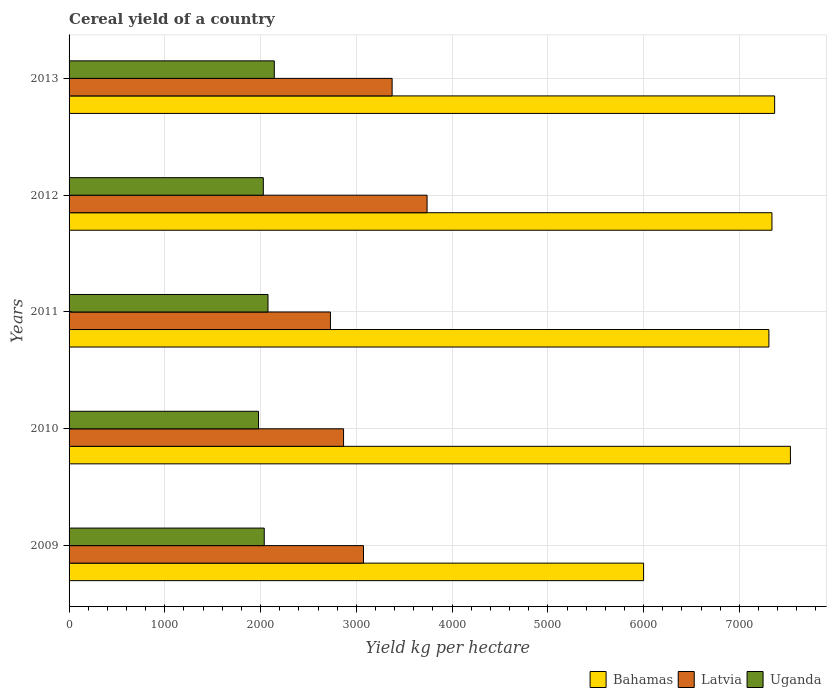How many different coloured bars are there?
Ensure brevity in your answer.  3. How many groups of bars are there?
Offer a very short reply. 5. How many bars are there on the 3rd tick from the bottom?
Provide a short and direct response. 3. In how many cases, is the number of bars for a given year not equal to the number of legend labels?
Offer a very short reply. 0. What is the total cereal yield in Uganda in 2010?
Provide a succinct answer. 1978.44. Across all years, what is the maximum total cereal yield in Uganda?
Offer a very short reply. 2143.29. Across all years, what is the minimum total cereal yield in Latvia?
Provide a short and direct response. 2729.47. In which year was the total cereal yield in Bahamas maximum?
Make the answer very short. 2010. What is the total total cereal yield in Latvia in the graph?
Provide a succinct answer. 1.58e+04. What is the difference between the total cereal yield in Bahamas in 2011 and that in 2012?
Keep it short and to the point. -31.91. What is the difference between the total cereal yield in Bahamas in 2009 and the total cereal yield in Latvia in 2011?
Provide a succinct answer. 3270.53. What is the average total cereal yield in Latvia per year?
Give a very brief answer. 3156.72. In the year 2013, what is the difference between the total cereal yield in Latvia and total cereal yield in Bahamas?
Your answer should be very brief. -3994.63. What is the ratio of the total cereal yield in Uganda in 2009 to that in 2011?
Provide a succinct answer. 0.98. Is the difference between the total cereal yield in Latvia in 2011 and 2012 greater than the difference between the total cereal yield in Bahamas in 2011 and 2012?
Your response must be concise. No. What is the difference between the highest and the second highest total cereal yield in Latvia?
Provide a succinct answer. 365.02. What is the difference between the highest and the lowest total cereal yield in Uganda?
Your response must be concise. 164.85. What does the 2nd bar from the top in 2012 represents?
Make the answer very short. Latvia. What does the 2nd bar from the bottom in 2011 represents?
Provide a short and direct response. Latvia. Is it the case that in every year, the sum of the total cereal yield in Uganda and total cereal yield in Bahamas is greater than the total cereal yield in Latvia?
Keep it short and to the point. Yes. How many bars are there?
Offer a very short reply. 15. Are all the bars in the graph horizontal?
Provide a succinct answer. Yes. Where does the legend appear in the graph?
Your answer should be compact. Bottom right. How many legend labels are there?
Give a very brief answer. 3. What is the title of the graph?
Make the answer very short. Cereal yield of a country. What is the label or title of the X-axis?
Provide a succinct answer. Yield kg per hectare. What is the label or title of the Y-axis?
Provide a succinct answer. Years. What is the Yield kg per hectare of Bahamas in 2009?
Ensure brevity in your answer.  6000. What is the Yield kg per hectare of Latvia in 2009?
Provide a short and direct response. 3074.88. What is the Yield kg per hectare of Uganda in 2009?
Your answer should be compact. 2038.33. What is the Yield kg per hectare of Bahamas in 2010?
Ensure brevity in your answer.  7533.33. What is the Yield kg per hectare in Latvia in 2010?
Your response must be concise. 2866.68. What is the Yield kg per hectare of Uganda in 2010?
Provide a succinct answer. 1978.44. What is the Yield kg per hectare of Bahamas in 2011?
Your answer should be compact. 7308.51. What is the Yield kg per hectare of Latvia in 2011?
Offer a terse response. 2729.47. What is the Yield kg per hectare in Uganda in 2011?
Your answer should be compact. 2077.56. What is the Yield kg per hectare of Bahamas in 2012?
Give a very brief answer. 7340.43. What is the Yield kg per hectare in Latvia in 2012?
Give a very brief answer. 3738.81. What is the Yield kg per hectare of Uganda in 2012?
Your response must be concise. 2028.6. What is the Yield kg per hectare of Bahamas in 2013?
Provide a short and direct response. 7368.42. What is the Yield kg per hectare of Latvia in 2013?
Offer a very short reply. 3373.79. What is the Yield kg per hectare of Uganda in 2013?
Your response must be concise. 2143.29. Across all years, what is the maximum Yield kg per hectare in Bahamas?
Your answer should be compact. 7533.33. Across all years, what is the maximum Yield kg per hectare of Latvia?
Provide a short and direct response. 3738.81. Across all years, what is the maximum Yield kg per hectare of Uganda?
Offer a terse response. 2143.29. Across all years, what is the minimum Yield kg per hectare of Bahamas?
Offer a terse response. 6000. Across all years, what is the minimum Yield kg per hectare in Latvia?
Make the answer very short. 2729.47. Across all years, what is the minimum Yield kg per hectare in Uganda?
Your response must be concise. 1978.44. What is the total Yield kg per hectare of Bahamas in the graph?
Offer a terse response. 3.56e+04. What is the total Yield kg per hectare in Latvia in the graph?
Make the answer very short. 1.58e+04. What is the total Yield kg per hectare in Uganda in the graph?
Provide a short and direct response. 1.03e+04. What is the difference between the Yield kg per hectare in Bahamas in 2009 and that in 2010?
Make the answer very short. -1533.33. What is the difference between the Yield kg per hectare of Latvia in 2009 and that in 2010?
Offer a very short reply. 208.19. What is the difference between the Yield kg per hectare of Uganda in 2009 and that in 2010?
Give a very brief answer. 59.88. What is the difference between the Yield kg per hectare of Bahamas in 2009 and that in 2011?
Your response must be concise. -1308.51. What is the difference between the Yield kg per hectare in Latvia in 2009 and that in 2011?
Your answer should be compact. 345.4. What is the difference between the Yield kg per hectare of Uganda in 2009 and that in 2011?
Give a very brief answer. -39.23. What is the difference between the Yield kg per hectare in Bahamas in 2009 and that in 2012?
Your answer should be very brief. -1340.43. What is the difference between the Yield kg per hectare in Latvia in 2009 and that in 2012?
Your response must be concise. -663.93. What is the difference between the Yield kg per hectare in Uganda in 2009 and that in 2012?
Give a very brief answer. 9.72. What is the difference between the Yield kg per hectare in Bahamas in 2009 and that in 2013?
Ensure brevity in your answer.  -1368.42. What is the difference between the Yield kg per hectare in Latvia in 2009 and that in 2013?
Offer a terse response. -298.91. What is the difference between the Yield kg per hectare in Uganda in 2009 and that in 2013?
Give a very brief answer. -104.97. What is the difference between the Yield kg per hectare in Bahamas in 2010 and that in 2011?
Keep it short and to the point. 224.82. What is the difference between the Yield kg per hectare in Latvia in 2010 and that in 2011?
Provide a short and direct response. 137.21. What is the difference between the Yield kg per hectare in Uganda in 2010 and that in 2011?
Provide a succinct answer. -99.11. What is the difference between the Yield kg per hectare of Bahamas in 2010 and that in 2012?
Provide a short and direct response. 192.91. What is the difference between the Yield kg per hectare of Latvia in 2010 and that in 2012?
Provide a short and direct response. -872.13. What is the difference between the Yield kg per hectare of Uganda in 2010 and that in 2012?
Give a very brief answer. -50.16. What is the difference between the Yield kg per hectare of Bahamas in 2010 and that in 2013?
Give a very brief answer. 164.91. What is the difference between the Yield kg per hectare in Latvia in 2010 and that in 2013?
Make the answer very short. -507.11. What is the difference between the Yield kg per hectare in Uganda in 2010 and that in 2013?
Keep it short and to the point. -164.85. What is the difference between the Yield kg per hectare in Bahamas in 2011 and that in 2012?
Your answer should be compact. -31.91. What is the difference between the Yield kg per hectare in Latvia in 2011 and that in 2012?
Your response must be concise. -1009.33. What is the difference between the Yield kg per hectare in Uganda in 2011 and that in 2012?
Give a very brief answer. 48.95. What is the difference between the Yield kg per hectare in Bahamas in 2011 and that in 2013?
Offer a terse response. -59.91. What is the difference between the Yield kg per hectare in Latvia in 2011 and that in 2013?
Give a very brief answer. -644.32. What is the difference between the Yield kg per hectare of Uganda in 2011 and that in 2013?
Make the answer very short. -65.74. What is the difference between the Yield kg per hectare of Bahamas in 2012 and that in 2013?
Your answer should be very brief. -28. What is the difference between the Yield kg per hectare of Latvia in 2012 and that in 2013?
Your answer should be compact. 365.02. What is the difference between the Yield kg per hectare in Uganda in 2012 and that in 2013?
Your answer should be compact. -114.69. What is the difference between the Yield kg per hectare in Bahamas in 2009 and the Yield kg per hectare in Latvia in 2010?
Give a very brief answer. 3133.32. What is the difference between the Yield kg per hectare in Bahamas in 2009 and the Yield kg per hectare in Uganda in 2010?
Offer a very short reply. 4021.56. What is the difference between the Yield kg per hectare of Latvia in 2009 and the Yield kg per hectare of Uganda in 2010?
Your response must be concise. 1096.43. What is the difference between the Yield kg per hectare in Bahamas in 2009 and the Yield kg per hectare in Latvia in 2011?
Your answer should be very brief. 3270.53. What is the difference between the Yield kg per hectare in Bahamas in 2009 and the Yield kg per hectare in Uganda in 2011?
Keep it short and to the point. 3922.44. What is the difference between the Yield kg per hectare in Latvia in 2009 and the Yield kg per hectare in Uganda in 2011?
Provide a succinct answer. 997.32. What is the difference between the Yield kg per hectare in Bahamas in 2009 and the Yield kg per hectare in Latvia in 2012?
Make the answer very short. 2261.19. What is the difference between the Yield kg per hectare of Bahamas in 2009 and the Yield kg per hectare of Uganda in 2012?
Your response must be concise. 3971.4. What is the difference between the Yield kg per hectare in Latvia in 2009 and the Yield kg per hectare in Uganda in 2012?
Your response must be concise. 1046.27. What is the difference between the Yield kg per hectare in Bahamas in 2009 and the Yield kg per hectare in Latvia in 2013?
Make the answer very short. 2626.21. What is the difference between the Yield kg per hectare in Bahamas in 2009 and the Yield kg per hectare in Uganda in 2013?
Provide a short and direct response. 3856.71. What is the difference between the Yield kg per hectare in Latvia in 2009 and the Yield kg per hectare in Uganda in 2013?
Provide a succinct answer. 931.58. What is the difference between the Yield kg per hectare in Bahamas in 2010 and the Yield kg per hectare in Latvia in 2011?
Provide a succinct answer. 4803.86. What is the difference between the Yield kg per hectare in Bahamas in 2010 and the Yield kg per hectare in Uganda in 2011?
Your answer should be very brief. 5455.78. What is the difference between the Yield kg per hectare of Latvia in 2010 and the Yield kg per hectare of Uganda in 2011?
Provide a short and direct response. 789.12. What is the difference between the Yield kg per hectare in Bahamas in 2010 and the Yield kg per hectare in Latvia in 2012?
Make the answer very short. 3794.53. What is the difference between the Yield kg per hectare in Bahamas in 2010 and the Yield kg per hectare in Uganda in 2012?
Keep it short and to the point. 5504.73. What is the difference between the Yield kg per hectare in Latvia in 2010 and the Yield kg per hectare in Uganda in 2012?
Provide a short and direct response. 838.08. What is the difference between the Yield kg per hectare of Bahamas in 2010 and the Yield kg per hectare of Latvia in 2013?
Give a very brief answer. 4159.55. What is the difference between the Yield kg per hectare of Bahamas in 2010 and the Yield kg per hectare of Uganda in 2013?
Offer a very short reply. 5390.04. What is the difference between the Yield kg per hectare of Latvia in 2010 and the Yield kg per hectare of Uganda in 2013?
Provide a succinct answer. 723.39. What is the difference between the Yield kg per hectare in Bahamas in 2011 and the Yield kg per hectare in Latvia in 2012?
Provide a short and direct response. 3569.7. What is the difference between the Yield kg per hectare of Bahamas in 2011 and the Yield kg per hectare of Uganda in 2012?
Ensure brevity in your answer.  5279.91. What is the difference between the Yield kg per hectare of Latvia in 2011 and the Yield kg per hectare of Uganda in 2012?
Provide a succinct answer. 700.87. What is the difference between the Yield kg per hectare in Bahamas in 2011 and the Yield kg per hectare in Latvia in 2013?
Your answer should be very brief. 3934.72. What is the difference between the Yield kg per hectare of Bahamas in 2011 and the Yield kg per hectare of Uganda in 2013?
Your response must be concise. 5165.22. What is the difference between the Yield kg per hectare of Latvia in 2011 and the Yield kg per hectare of Uganda in 2013?
Provide a succinct answer. 586.18. What is the difference between the Yield kg per hectare in Bahamas in 2012 and the Yield kg per hectare in Latvia in 2013?
Your answer should be very brief. 3966.64. What is the difference between the Yield kg per hectare of Bahamas in 2012 and the Yield kg per hectare of Uganda in 2013?
Keep it short and to the point. 5197.13. What is the difference between the Yield kg per hectare in Latvia in 2012 and the Yield kg per hectare in Uganda in 2013?
Ensure brevity in your answer.  1595.51. What is the average Yield kg per hectare in Bahamas per year?
Offer a very short reply. 7110.14. What is the average Yield kg per hectare in Latvia per year?
Ensure brevity in your answer.  3156.72. What is the average Yield kg per hectare of Uganda per year?
Give a very brief answer. 2053.24. In the year 2009, what is the difference between the Yield kg per hectare in Bahamas and Yield kg per hectare in Latvia?
Keep it short and to the point. 2925.12. In the year 2009, what is the difference between the Yield kg per hectare in Bahamas and Yield kg per hectare in Uganda?
Offer a terse response. 3961.67. In the year 2009, what is the difference between the Yield kg per hectare of Latvia and Yield kg per hectare of Uganda?
Offer a terse response. 1036.55. In the year 2010, what is the difference between the Yield kg per hectare in Bahamas and Yield kg per hectare in Latvia?
Offer a very short reply. 4666.65. In the year 2010, what is the difference between the Yield kg per hectare in Bahamas and Yield kg per hectare in Uganda?
Give a very brief answer. 5554.89. In the year 2010, what is the difference between the Yield kg per hectare in Latvia and Yield kg per hectare in Uganda?
Offer a terse response. 888.24. In the year 2011, what is the difference between the Yield kg per hectare in Bahamas and Yield kg per hectare in Latvia?
Offer a very short reply. 4579.04. In the year 2011, what is the difference between the Yield kg per hectare in Bahamas and Yield kg per hectare in Uganda?
Your answer should be very brief. 5230.95. In the year 2011, what is the difference between the Yield kg per hectare in Latvia and Yield kg per hectare in Uganda?
Make the answer very short. 651.92. In the year 2012, what is the difference between the Yield kg per hectare of Bahamas and Yield kg per hectare of Latvia?
Offer a terse response. 3601.62. In the year 2012, what is the difference between the Yield kg per hectare of Bahamas and Yield kg per hectare of Uganda?
Offer a very short reply. 5311.82. In the year 2012, what is the difference between the Yield kg per hectare of Latvia and Yield kg per hectare of Uganda?
Provide a succinct answer. 1710.2. In the year 2013, what is the difference between the Yield kg per hectare in Bahamas and Yield kg per hectare in Latvia?
Keep it short and to the point. 3994.63. In the year 2013, what is the difference between the Yield kg per hectare of Bahamas and Yield kg per hectare of Uganda?
Provide a succinct answer. 5225.13. In the year 2013, what is the difference between the Yield kg per hectare of Latvia and Yield kg per hectare of Uganda?
Keep it short and to the point. 1230.49. What is the ratio of the Yield kg per hectare in Bahamas in 2009 to that in 2010?
Ensure brevity in your answer.  0.8. What is the ratio of the Yield kg per hectare of Latvia in 2009 to that in 2010?
Provide a succinct answer. 1.07. What is the ratio of the Yield kg per hectare of Uganda in 2009 to that in 2010?
Offer a terse response. 1.03. What is the ratio of the Yield kg per hectare of Bahamas in 2009 to that in 2011?
Provide a short and direct response. 0.82. What is the ratio of the Yield kg per hectare of Latvia in 2009 to that in 2011?
Your answer should be very brief. 1.13. What is the ratio of the Yield kg per hectare in Uganda in 2009 to that in 2011?
Your response must be concise. 0.98. What is the ratio of the Yield kg per hectare in Bahamas in 2009 to that in 2012?
Your answer should be very brief. 0.82. What is the ratio of the Yield kg per hectare of Latvia in 2009 to that in 2012?
Offer a very short reply. 0.82. What is the ratio of the Yield kg per hectare of Uganda in 2009 to that in 2012?
Give a very brief answer. 1. What is the ratio of the Yield kg per hectare of Bahamas in 2009 to that in 2013?
Keep it short and to the point. 0.81. What is the ratio of the Yield kg per hectare of Latvia in 2009 to that in 2013?
Make the answer very short. 0.91. What is the ratio of the Yield kg per hectare of Uganda in 2009 to that in 2013?
Your answer should be compact. 0.95. What is the ratio of the Yield kg per hectare of Bahamas in 2010 to that in 2011?
Ensure brevity in your answer.  1.03. What is the ratio of the Yield kg per hectare of Latvia in 2010 to that in 2011?
Provide a succinct answer. 1.05. What is the ratio of the Yield kg per hectare in Uganda in 2010 to that in 2011?
Keep it short and to the point. 0.95. What is the ratio of the Yield kg per hectare in Bahamas in 2010 to that in 2012?
Offer a terse response. 1.03. What is the ratio of the Yield kg per hectare in Latvia in 2010 to that in 2012?
Your response must be concise. 0.77. What is the ratio of the Yield kg per hectare of Uganda in 2010 to that in 2012?
Your answer should be very brief. 0.98. What is the ratio of the Yield kg per hectare of Bahamas in 2010 to that in 2013?
Keep it short and to the point. 1.02. What is the ratio of the Yield kg per hectare in Latvia in 2010 to that in 2013?
Give a very brief answer. 0.85. What is the ratio of the Yield kg per hectare in Uganda in 2010 to that in 2013?
Keep it short and to the point. 0.92. What is the ratio of the Yield kg per hectare of Latvia in 2011 to that in 2012?
Provide a succinct answer. 0.73. What is the ratio of the Yield kg per hectare of Uganda in 2011 to that in 2012?
Offer a terse response. 1.02. What is the ratio of the Yield kg per hectare of Bahamas in 2011 to that in 2013?
Offer a terse response. 0.99. What is the ratio of the Yield kg per hectare of Latvia in 2011 to that in 2013?
Ensure brevity in your answer.  0.81. What is the ratio of the Yield kg per hectare in Uganda in 2011 to that in 2013?
Keep it short and to the point. 0.97. What is the ratio of the Yield kg per hectare in Latvia in 2012 to that in 2013?
Give a very brief answer. 1.11. What is the ratio of the Yield kg per hectare in Uganda in 2012 to that in 2013?
Ensure brevity in your answer.  0.95. What is the difference between the highest and the second highest Yield kg per hectare in Bahamas?
Keep it short and to the point. 164.91. What is the difference between the highest and the second highest Yield kg per hectare of Latvia?
Make the answer very short. 365.02. What is the difference between the highest and the second highest Yield kg per hectare in Uganda?
Give a very brief answer. 65.74. What is the difference between the highest and the lowest Yield kg per hectare in Bahamas?
Offer a terse response. 1533.33. What is the difference between the highest and the lowest Yield kg per hectare of Latvia?
Provide a short and direct response. 1009.33. What is the difference between the highest and the lowest Yield kg per hectare of Uganda?
Offer a terse response. 164.85. 